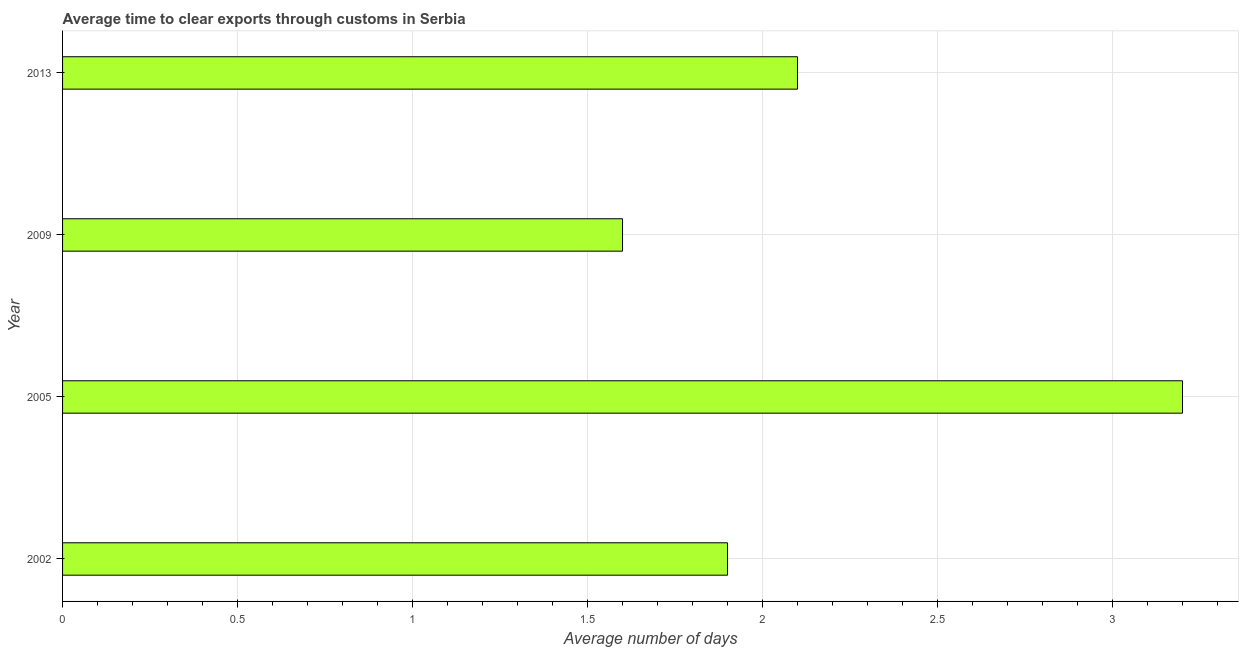Does the graph contain any zero values?
Offer a terse response. No. Does the graph contain grids?
Ensure brevity in your answer.  Yes. What is the title of the graph?
Provide a succinct answer. Average time to clear exports through customs in Serbia. What is the label or title of the X-axis?
Make the answer very short. Average number of days. What is the label or title of the Y-axis?
Provide a succinct answer. Year. What is the sum of the time to clear exports through customs?
Give a very brief answer. 8.8. What is the difference between the time to clear exports through customs in 2002 and 2005?
Offer a very short reply. -1.3. What is the average time to clear exports through customs per year?
Keep it short and to the point. 2.2. What is the median time to clear exports through customs?
Provide a succinct answer. 2. In how many years, is the time to clear exports through customs greater than 1.8 days?
Your answer should be compact. 3. What is the ratio of the time to clear exports through customs in 2002 to that in 2009?
Give a very brief answer. 1.19. Is the time to clear exports through customs in 2005 less than that in 2013?
Ensure brevity in your answer.  No. What is the difference between the highest and the second highest time to clear exports through customs?
Offer a very short reply. 1.1. What is the difference between the highest and the lowest time to clear exports through customs?
Make the answer very short. 1.6. In how many years, is the time to clear exports through customs greater than the average time to clear exports through customs taken over all years?
Ensure brevity in your answer.  1. How many bars are there?
Make the answer very short. 4. What is the difference between two consecutive major ticks on the X-axis?
Give a very brief answer. 0.5. What is the Average number of days in 2005?
Your answer should be compact. 3.2. What is the difference between the Average number of days in 2002 and 2009?
Make the answer very short. 0.3. What is the difference between the Average number of days in 2005 and 2013?
Provide a short and direct response. 1.1. What is the difference between the Average number of days in 2009 and 2013?
Give a very brief answer. -0.5. What is the ratio of the Average number of days in 2002 to that in 2005?
Make the answer very short. 0.59. What is the ratio of the Average number of days in 2002 to that in 2009?
Provide a short and direct response. 1.19. What is the ratio of the Average number of days in 2002 to that in 2013?
Make the answer very short. 0.91. What is the ratio of the Average number of days in 2005 to that in 2013?
Give a very brief answer. 1.52. What is the ratio of the Average number of days in 2009 to that in 2013?
Provide a short and direct response. 0.76. 